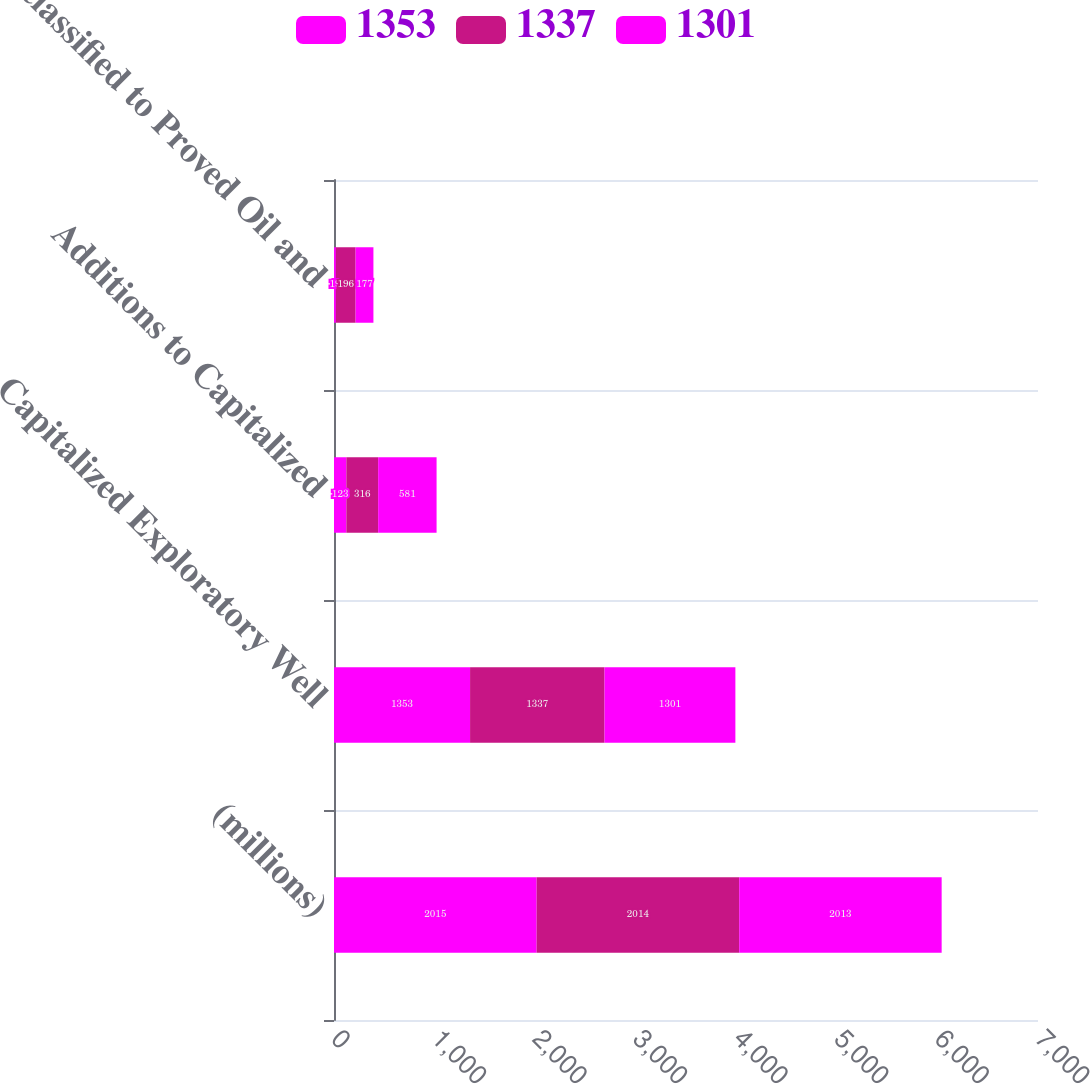<chart> <loc_0><loc_0><loc_500><loc_500><stacked_bar_chart><ecel><fcel>(millions)<fcel>Capitalized Exploratory Well<fcel>Additions to Capitalized<fcel>Reclassified to Proved Oil and<nl><fcel>1353<fcel>2015<fcel>1353<fcel>123<fcel>19<nl><fcel>1337<fcel>2014<fcel>1337<fcel>316<fcel>196<nl><fcel>1301<fcel>2013<fcel>1301<fcel>581<fcel>177<nl></chart> 